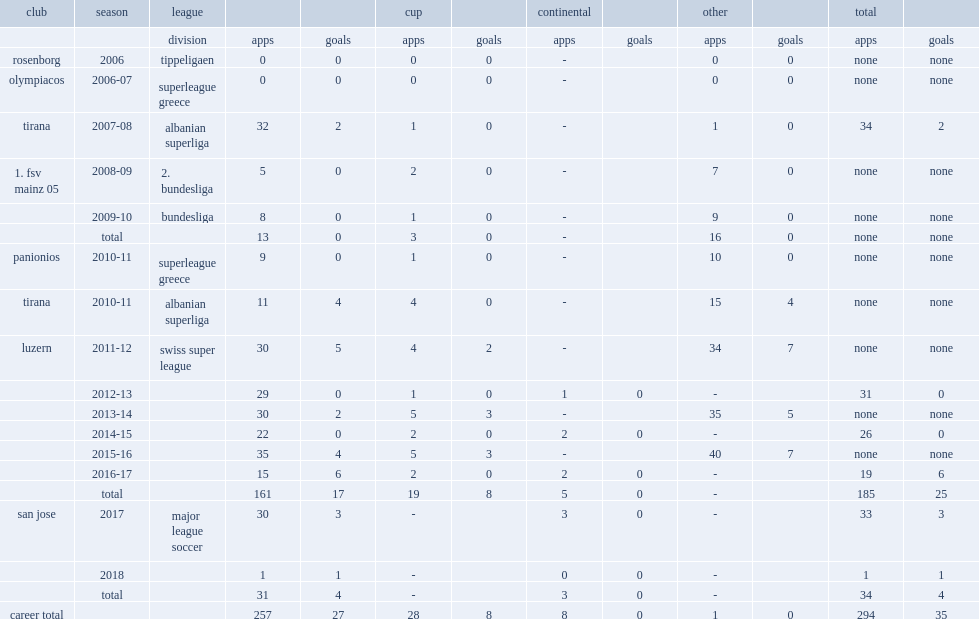Could you parse the entire table as a dict? {'header': ['club', 'season', 'league', '', '', 'cup', '', 'continental', '', 'other', '', 'total', ''], 'rows': [['', '', 'division', 'apps', 'goals', 'apps', 'goals', 'apps', 'goals', 'apps', 'goals', 'apps', 'goals'], ['rosenborg', '2006', 'tippeligaen', '0', '0', '0', '0', '-', '', '0', '0', 'none', 'none'], ['olympiacos', '2006-07', 'superleague greece', '0', '0', '0', '0', '-', '', '0', '0', 'none', 'none'], ['tirana', '2007-08', 'albanian superliga', '32', '2', '1', '0', '-', '', '1', '0', '34', '2'], ['1. fsv mainz 05', '2008-09', '2. bundesliga', '5', '0', '2', '0', '-', '', '7', '0', 'none', 'none'], ['', '2009-10', 'bundesliga', '8', '0', '1', '0', '-', '', '9', '0', 'none', 'none'], ['', 'total', '', '13', '0', '3', '0', '-', '', '16', '0', 'none', 'none'], ['panionios', '2010-11', 'superleague greece', '9', '0', '1', '0', '-', '', '10', '0', 'none', 'none'], ['tirana', '2010-11', 'albanian superliga', '11', '4', '4', '0', '-', '', '15', '4', 'none', 'none'], ['luzern', '2011-12', 'swiss super league', '30', '5', '4', '2', '-', '', '34', '7', 'none', 'none'], ['', '2012-13', '', '29', '0', '1', '0', '1', '0', '-', '', '31', '0'], ['', '2013-14', '', '30', '2', '5', '3', '-', '', '35', '5', 'none', 'none'], ['', '2014-15', '', '22', '0', '2', '0', '2', '0', '-', '', '26', '0'], ['', '2015-16', '', '35', '4', '5', '3', '-', '', '40', '7', 'none', 'none'], ['', '2016-17', '', '15', '6', '2', '0', '2', '0', '-', '', '19', '6'], ['', 'total', '', '161', '17', '19', '8', '5', '0', '-', '', '185', '25'], ['san jose', '2017', 'major league soccer', '30', '3', '-', '', '3', '0', '-', '', '33', '3'], ['', '2018', '', '1', '1', '-', '', '0', '0', '-', '', '1', '1'], ['', 'total', '', '31', '4', '-', '', '3', '0', '-', '', '34', '4'], ['career total', '', '', '257', '27', '28', '8', '8', '0', '1', '0', '294', '35']]} Which club did jahmir hyka play for in 2007-08? Tirana. 